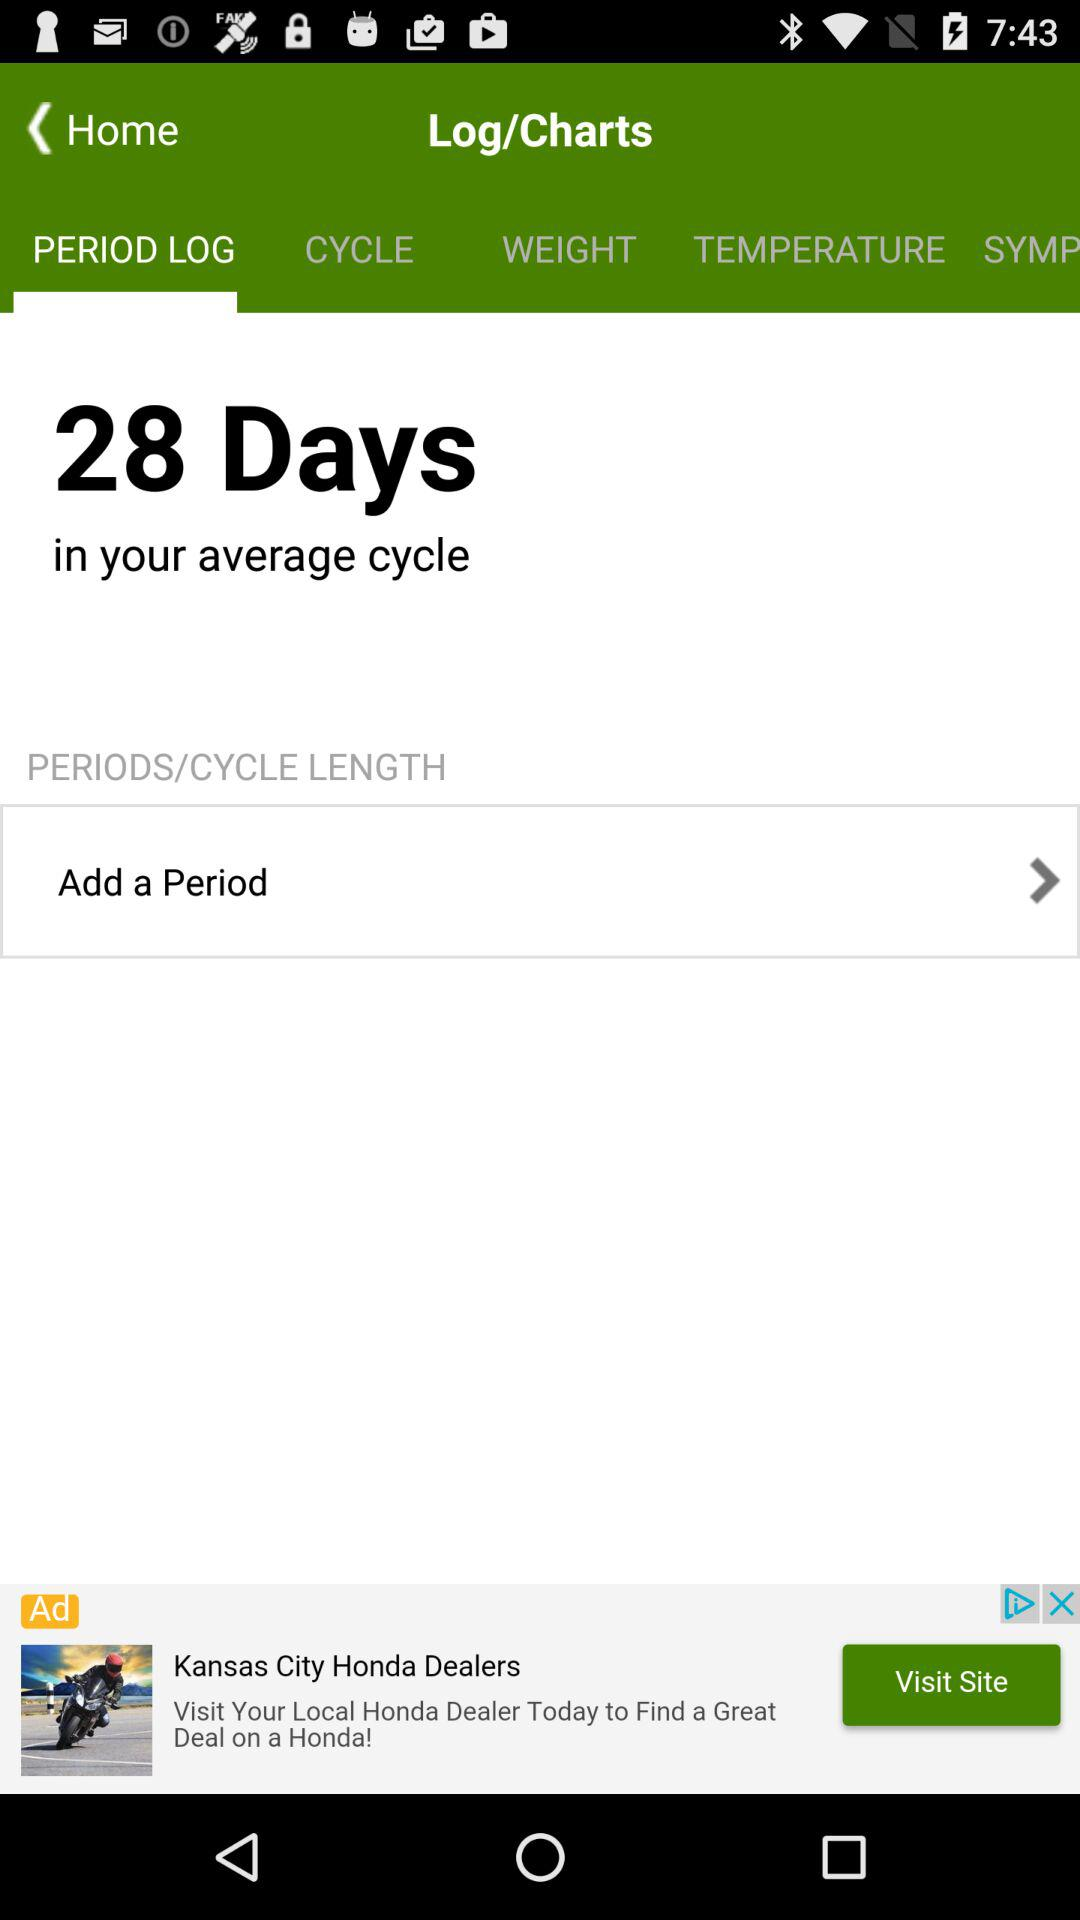How many days are there in the average cycle? There are 28 days in the average cycle. 